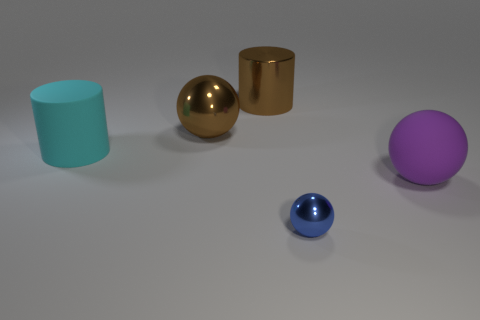Add 4 big red metallic spheres. How many objects exist? 9 Subtract all cylinders. How many objects are left? 3 Subtract 1 brown balls. How many objects are left? 4 Subtract all big matte cylinders. Subtract all blue shiny things. How many objects are left? 3 Add 2 matte things. How many matte things are left? 4 Add 1 tiny green metal blocks. How many tiny green metal blocks exist? 1 